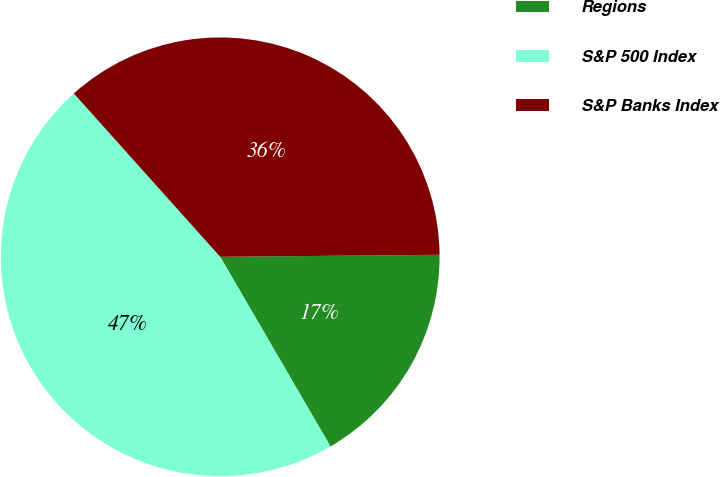<chart> <loc_0><loc_0><loc_500><loc_500><pie_chart><fcel>Regions<fcel>S&P 500 Index<fcel>S&P Banks Index<nl><fcel>16.76%<fcel>46.75%<fcel>36.48%<nl></chart> 